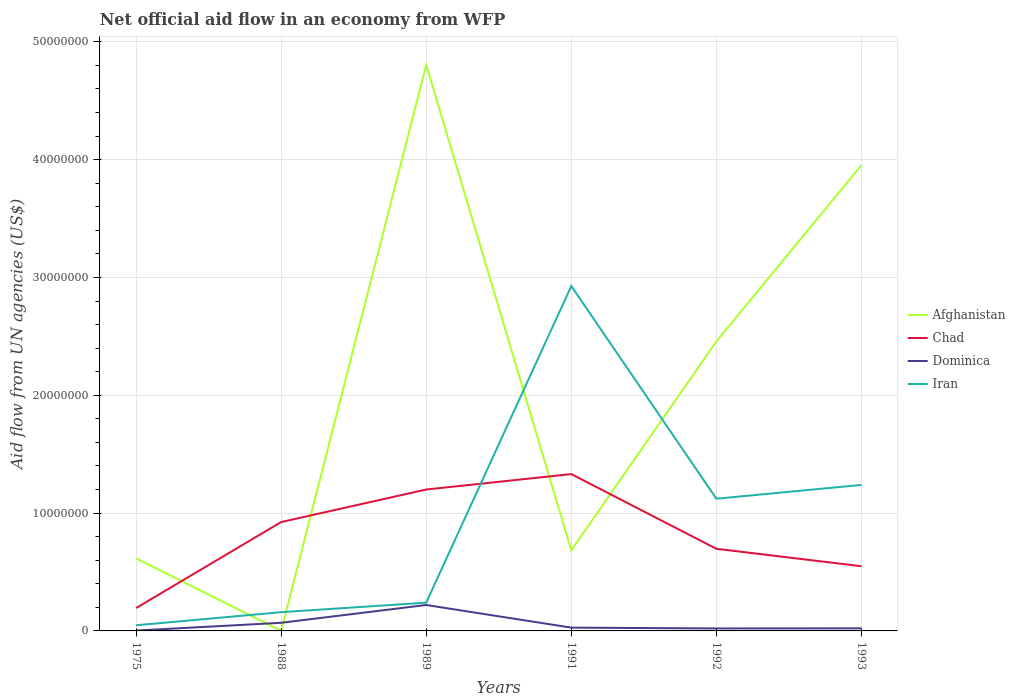Does the line corresponding to Afghanistan intersect with the line corresponding to Iran?
Give a very brief answer. Yes. Across all years, what is the maximum net official aid flow in Chad?
Provide a short and direct response. 1.94e+06. In which year was the net official aid flow in Afghanistan maximum?
Ensure brevity in your answer.  1988. What is the total net official aid flow in Chad in the graph?
Keep it short and to the point. 7.82e+06. What is the difference between the highest and the second highest net official aid flow in Chad?
Offer a very short reply. 1.14e+07. Is the net official aid flow in Dominica strictly greater than the net official aid flow in Chad over the years?
Make the answer very short. Yes. Does the graph contain grids?
Provide a succinct answer. Yes. What is the title of the graph?
Ensure brevity in your answer.  Net official aid flow in an economy from WFP. Does "Monaco" appear as one of the legend labels in the graph?
Your answer should be very brief. No. What is the label or title of the X-axis?
Your answer should be very brief. Years. What is the label or title of the Y-axis?
Keep it short and to the point. Aid flow from UN agencies (US$). What is the Aid flow from UN agencies (US$) in Afghanistan in 1975?
Your answer should be very brief. 6.16e+06. What is the Aid flow from UN agencies (US$) in Chad in 1975?
Keep it short and to the point. 1.94e+06. What is the Aid flow from UN agencies (US$) in Dominica in 1975?
Your answer should be very brief. 3.00e+04. What is the Aid flow from UN agencies (US$) in Iran in 1975?
Offer a terse response. 4.80e+05. What is the Aid flow from UN agencies (US$) in Afghanistan in 1988?
Provide a succinct answer. 10000. What is the Aid flow from UN agencies (US$) of Chad in 1988?
Offer a terse response. 9.24e+06. What is the Aid flow from UN agencies (US$) of Dominica in 1988?
Your answer should be compact. 6.90e+05. What is the Aid flow from UN agencies (US$) in Iran in 1988?
Your answer should be compact. 1.59e+06. What is the Aid flow from UN agencies (US$) in Afghanistan in 1989?
Your answer should be compact. 4.80e+07. What is the Aid flow from UN agencies (US$) of Chad in 1989?
Offer a very short reply. 1.20e+07. What is the Aid flow from UN agencies (US$) in Dominica in 1989?
Keep it short and to the point. 2.20e+06. What is the Aid flow from UN agencies (US$) of Iran in 1989?
Offer a terse response. 2.40e+06. What is the Aid flow from UN agencies (US$) in Afghanistan in 1991?
Ensure brevity in your answer.  6.84e+06. What is the Aid flow from UN agencies (US$) of Chad in 1991?
Provide a succinct answer. 1.33e+07. What is the Aid flow from UN agencies (US$) of Iran in 1991?
Provide a short and direct response. 2.93e+07. What is the Aid flow from UN agencies (US$) in Afghanistan in 1992?
Make the answer very short. 2.46e+07. What is the Aid flow from UN agencies (US$) in Chad in 1992?
Keep it short and to the point. 6.97e+06. What is the Aid flow from UN agencies (US$) in Iran in 1992?
Offer a terse response. 1.12e+07. What is the Aid flow from UN agencies (US$) of Afghanistan in 1993?
Make the answer very short. 3.95e+07. What is the Aid flow from UN agencies (US$) in Chad in 1993?
Ensure brevity in your answer.  5.49e+06. What is the Aid flow from UN agencies (US$) in Iran in 1993?
Offer a terse response. 1.24e+07. Across all years, what is the maximum Aid flow from UN agencies (US$) in Afghanistan?
Your answer should be very brief. 4.80e+07. Across all years, what is the maximum Aid flow from UN agencies (US$) of Chad?
Ensure brevity in your answer.  1.33e+07. Across all years, what is the maximum Aid flow from UN agencies (US$) in Dominica?
Your answer should be very brief. 2.20e+06. Across all years, what is the maximum Aid flow from UN agencies (US$) of Iran?
Ensure brevity in your answer.  2.93e+07. Across all years, what is the minimum Aid flow from UN agencies (US$) of Afghanistan?
Offer a very short reply. 10000. Across all years, what is the minimum Aid flow from UN agencies (US$) of Chad?
Your answer should be very brief. 1.94e+06. Across all years, what is the minimum Aid flow from UN agencies (US$) of Iran?
Make the answer very short. 4.80e+05. What is the total Aid flow from UN agencies (US$) of Afghanistan in the graph?
Offer a terse response. 1.25e+08. What is the total Aid flow from UN agencies (US$) in Chad in the graph?
Provide a short and direct response. 4.90e+07. What is the total Aid flow from UN agencies (US$) in Dominica in the graph?
Make the answer very short. 3.63e+06. What is the total Aid flow from UN agencies (US$) in Iran in the graph?
Provide a short and direct response. 5.74e+07. What is the difference between the Aid flow from UN agencies (US$) of Afghanistan in 1975 and that in 1988?
Provide a succinct answer. 6.15e+06. What is the difference between the Aid flow from UN agencies (US$) of Chad in 1975 and that in 1988?
Your response must be concise. -7.30e+06. What is the difference between the Aid flow from UN agencies (US$) of Dominica in 1975 and that in 1988?
Provide a short and direct response. -6.60e+05. What is the difference between the Aid flow from UN agencies (US$) of Iran in 1975 and that in 1988?
Offer a very short reply. -1.11e+06. What is the difference between the Aid flow from UN agencies (US$) of Afghanistan in 1975 and that in 1989?
Your response must be concise. -4.19e+07. What is the difference between the Aid flow from UN agencies (US$) of Chad in 1975 and that in 1989?
Your response must be concise. -1.01e+07. What is the difference between the Aid flow from UN agencies (US$) of Dominica in 1975 and that in 1989?
Your response must be concise. -2.17e+06. What is the difference between the Aid flow from UN agencies (US$) of Iran in 1975 and that in 1989?
Make the answer very short. -1.92e+06. What is the difference between the Aid flow from UN agencies (US$) of Afghanistan in 1975 and that in 1991?
Offer a terse response. -6.80e+05. What is the difference between the Aid flow from UN agencies (US$) in Chad in 1975 and that in 1991?
Provide a succinct answer. -1.14e+07. What is the difference between the Aid flow from UN agencies (US$) in Iran in 1975 and that in 1991?
Give a very brief answer. -2.88e+07. What is the difference between the Aid flow from UN agencies (US$) in Afghanistan in 1975 and that in 1992?
Make the answer very short. -1.84e+07. What is the difference between the Aid flow from UN agencies (US$) in Chad in 1975 and that in 1992?
Ensure brevity in your answer.  -5.03e+06. What is the difference between the Aid flow from UN agencies (US$) in Iran in 1975 and that in 1992?
Make the answer very short. -1.07e+07. What is the difference between the Aid flow from UN agencies (US$) of Afghanistan in 1975 and that in 1993?
Make the answer very short. -3.34e+07. What is the difference between the Aid flow from UN agencies (US$) of Chad in 1975 and that in 1993?
Offer a terse response. -3.55e+06. What is the difference between the Aid flow from UN agencies (US$) in Iran in 1975 and that in 1993?
Your response must be concise. -1.19e+07. What is the difference between the Aid flow from UN agencies (US$) of Afghanistan in 1988 and that in 1989?
Your response must be concise. -4.80e+07. What is the difference between the Aid flow from UN agencies (US$) of Chad in 1988 and that in 1989?
Make the answer very short. -2.76e+06. What is the difference between the Aid flow from UN agencies (US$) of Dominica in 1988 and that in 1989?
Provide a short and direct response. -1.51e+06. What is the difference between the Aid flow from UN agencies (US$) in Iran in 1988 and that in 1989?
Make the answer very short. -8.10e+05. What is the difference between the Aid flow from UN agencies (US$) of Afghanistan in 1988 and that in 1991?
Give a very brief answer. -6.83e+06. What is the difference between the Aid flow from UN agencies (US$) in Chad in 1988 and that in 1991?
Your response must be concise. -4.07e+06. What is the difference between the Aid flow from UN agencies (US$) in Iran in 1988 and that in 1991?
Offer a terse response. -2.77e+07. What is the difference between the Aid flow from UN agencies (US$) of Afghanistan in 1988 and that in 1992?
Your answer should be very brief. -2.46e+07. What is the difference between the Aid flow from UN agencies (US$) in Chad in 1988 and that in 1992?
Your answer should be very brief. 2.27e+06. What is the difference between the Aid flow from UN agencies (US$) in Dominica in 1988 and that in 1992?
Ensure brevity in your answer.  4.80e+05. What is the difference between the Aid flow from UN agencies (US$) of Iran in 1988 and that in 1992?
Your answer should be compact. -9.63e+06. What is the difference between the Aid flow from UN agencies (US$) in Afghanistan in 1988 and that in 1993?
Provide a succinct answer. -3.95e+07. What is the difference between the Aid flow from UN agencies (US$) of Chad in 1988 and that in 1993?
Make the answer very short. 3.75e+06. What is the difference between the Aid flow from UN agencies (US$) in Dominica in 1988 and that in 1993?
Offer a terse response. 4.70e+05. What is the difference between the Aid flow from UN agencies (US$) of Iran in 1988 and that in 1993?
Your response must be concise. -1.08e+07. What is the difference between the Aid flow from UN agencies (US$) of Afghanistan in 1989 and that in 1991?
Provide a succinct answer. 4.12e+07. What is the difference between the Aid flow from UN agencies (US$) in Chad in 1989 and that in 1991?
Provide a succinct answer. -1.31e+06. What is the difference between the Aid flow from UN agencies (US$) of Dominica in 1989 and that in 1991?
Your answer should be very brief. 1.92e+06. What is the difference between the Aid flow from UN agencies (US$) of Iran in 1989 and that in 1991?
Provide a short and direct response. -2.69e+07. What is the difference between the Aid flow from UN agencies (US$) in Afghanistan in 1989 and that in 1992?
Your answer should be compact. 2.35e+07. What is the difference between the Aid flow from UN agencies (US$) in Chad in 1989 and that in 1992?
Give a very brief answer. 5.03e+06. What is the difference between the Aid flow from UN agencies (US$) of Dominica in 1989 and that in 1992?
Offer a terse response. 1.99e+06. What is the difference between the Aid flow from UN agencies (US$) of Iran in 1989 and that in 1992?
Ensure brevity in your answer.  -8.82e+06. What is the difference between the Aid flow from UN agencies (US$) of Afghanistan in 1989 and that in 1993?
Your answer should be very brief. 8.51e+06. What is the difference between the Aid flow from UN agencies (US$) in Chad in 1989 and that in 1993?
Your answer should be very brief. 6.51e+06. What is the difference between the Aid flow from UN agencies (US$) in Dominica in 1989 and that in 1993?
Ensure brevity in your answer.  1.98e+06. What is the difference between the Aid flow from UN agencies (US$) of Iran in 1989 and that in 1993?
Keep it short and to the point. -9.99e+06. What is the difference between the Aid flow from UN agencies (US$) of Afghanistan in 1991 and that in 1992?
Give a very brief answer. -1.77e+07. What is the difference between the Aid flow from UN agencies (US$) of Chad in 1991 and that in 1992?
Ensure brevity in your answer.  6.34e+06. What is the difference between the Aid flow from UN agencies (US$) in Dominica in 1991 and that in 1992?
Offer a terse response. 7.00e+04. What is the difference between the Aid flow from UN agencies (US$) in Iran in 1991 and that in 1992?
Ensure brevity in your answer.  1.80e+07. What is the difference between the Aid flow from UN agencies (US$) of Afghanistan in 1991 and that in 1993?
Your answer should be very brief. -3.27e+07. What is the difference between the Aid flow from UN agencies (US$) of Chad in 1991 and that in 1993?
Your response must be concise. 7.82e+06. What is the difference between the Aid flow from UN agencies (US$) in Iran in 1991 and that in 1993?
Offer a very short reply. 1.69e+07. What is the difference between the Aid flow from UN agencies (US$) in Afghanistan in 1992 and that in 1993?
Ensure brevity in your answer.  -1.50e+07. What is the difference between the Aid flow from UN agencies (US$) of Chad in 1992 and that in 1993?
Give a very brief answer. 1.48e+06. What is the difference between the Aid flow from UN agencies (US$) of Dominica in 1992 and that in 1993?
Provide a short and direct response. -10000. What is the difference between the Aid flow from UN agencies (US$) in Iran in 1992 and that in 1993?
Offer a very short reply. -1.17e+06. What is the difference between the Aid flow from UN agencies (US$) of Afghanistan in 1975 and the Aid flow from UN agencies (US$) of Chad in 1988?
Your answer should be very brief. -3.08e+06. What is the difference between the Aid flow from UN agencies (US$) in Afghanistan in 1975 and the Aid flow from UN agencies (US$) in Dominica in 1988?
Offer a terse response. 5.47e+06. What is the difference between the Aid flow from UN agencies (US$) of Afghanistan in 1975 and the Aid flow from UN agencies (US$) of Iran in 1988?
Give a very brief answer. 4.57e+06. What is the difference between the Aid flow from UN agencies (US$) in Chad in 1975 and the Aid flow from UN agencies (US$) in Dominica in 1988?
Offer a very short reply. 1.25e+06. What is the difference between the Aid flow from UN agencies (US$) of Chad in 1975 and the Aid flow from UN agencies (US$) of Iran in 1988?
Your answer should be compact. 3.50e+05. What is the difference between the Aid flow from UN agencies (US$) of Dominica in 1975 and the Aid flow from UN agencies (US$) of Iran in 1988?
Offer a terse response. -1.56e+06. What is the difference between the Aid flow from UN agencies (US$) of Afghanistan in 1975 and the Aid flow from UN agencies (US$) of Chad in 1989?
Offer a terse response. -5.84e+06. What is the difference between the Aid flow from UN agencies (US$) in Afghanistan in 1975 and the Aid flow from UN agencies (US$) in Dominica in 1989?
Make the answer very short. 3.96e+06. What is the difference between the Aid flow from UN agencies (US$) of Afghanistan in 1975 and the Aid flow from UN agencies (US$) of Iran in 1989?
Your answer should be very brief. 3.76e+06. What is the difference between the Aid flow from UN agencies (US$) of Chad in 1975 and the Aid flow from UN agencies (US$) of Iran in 1989?
Your response must be concise. -4.60e+05. What is the difference between the Aid flow from UN agencies (US$) of Dominica in 1975 and the Aid flow from UN agencies (US$) of Iran in 1989?
Ensure brevity in your answer.  -2.37e+06. What is the difference between the Aid flow from UN agencies (US$) of Afghanistan in 1975 and the Aid flow from UN agencies (US$) of Chad in 1991?
Your response must be concise. -7.15e+06. What is the difference between the Aid flow from UN agencies (US$) of Afghanistan in 1975 and the Aid flow from UN agencies (US$) of Dominica in 1991?
Give a very brief answer. 5.88e+06. What is the difference between the Aid flow from UN agencies (US$) of Afghanistan in 1975 and the Aid flow from UN agencies (US$) of Iran in 1991?
Give a very brief answer. -2.31e+07. What is the difference between the Aid flow from UN agencies (US$) in Chad in 1975 and the Aid flow from UN agencies (US$) in Dominica in 1991?
Keep it short and to the point. 1.66e+06. What is the difference between the Aid flow from UN agencies (US$) in Chad in 1975 and the Aid flow from UN agencies (US$) in Iran in 1991?
Offer a very short reply. -2.73e+07. What is the difference between the Aid flow from UN agencies (US$) of Dominica in 1975 and the Aid flow from UN agencies (US$) of Iran in 1991?
Keep it short and to the point. -2.92e+07. What is the difference between the Aid flow from UN agencies (US$) of Afghanistan in 1975 and the Aid flow from UN agencies (US$) of Chad in 1992?
Your answer should be compact. -8.10e+05. What is the difference between the Aid flow from UN agencies (US$) of Afghanistan in 1975 and the Aid flow from UN agencies (US$) of Dominica in 1992?
Provide a short and direct response. 5.95e+06. What is the difference between the Aid flow from UN agencies (US$) in Afghanistan in 1975 and the Aid flow from UN agencies (US$) in Iran in 1992?
Keep it short and to the point. -5.06e+06. What is the difference between the Aid flow from UN agencies (US$) of Chad in 1975 and the Aid flow from UN agencies (US$) of Dominica in 1992?
Keep it short and to the point. 1.73e+06. What is the difference between the Aid flow from UN agencies (US$) in Chad in 1975 and the Aid flow from UN agencies (US$) in Iran in 1992?
Your answer should be compact. -9.28e+06. What is the difference between the Aid flow from UN agencies (US$) in Dominica in 1975 and the Aid flow from UN agencies (US$) in Iran in 1992?
Provide a short and direct response. -1.12e+07. What is the difference between the Aid flow from UN agencies (US$) in Afghanistan in 1975 and the Aid flow from UN agencies (US$) in Chad in 1993?
Offer a very short reply. 6.70e+05. What is the difference between the Aid flow from UN agencies (US$) of Afghanistan in 1975 and the Aid flow from UN agencies (US$) of Dominica in 1993?
Offer a very short reply. 5.94e+06. What is the difference between the Aid flow from UN agencies (US$) in Afghanistan in 1975 and the Aid flow from UN agencies (US$) in Iran in 1993?
Ensure brevity in your answer.  -6.23e+06. What is the difference between the Aid flow from UN agencies (US$) of Chad in 1975 and the Aid flow from UN agencies (US$) of Dominica in 1993?
Give a very brief answer. 1.72e+06. What is the difference between the Aid flow from UN agencies (US$) in Chad in 1975 and the Aid flow from UN agencies (US$) in Iran in 1993?
Keep it short and to the point. -1.04e+07. What is the difference between the Aid flow from UN agencies (US$) of Dominica in 1975 and the Aid flow from UN agencies (US$) of Iran in 1993?
Your answer should be compact. -1.24e+07. What is the difference between the Aid flow from UN agencies (US$) in Afghanistan in 1988 and the Aid flow from UN agencies (US$) in Chad in 1989?
Provide a short and direct response. -1.20e+07. What is the difference between the Aid flow from UN agencies (US$) in Afghanistan in 1988 and the Aid flow from UN agencies (US$) in Dominica in 1989?
Provide a succinct answer. -2.19e+06. What is the difference between the Aid flow from UN agencies (US$) of Afghanistan in 1988 and the Aid flow from UN agencies (US$) of Iran in 1989?
Keep it short and to the point. -2.39e+06. What is the difference between the Aid flow from UN agencies (US$) of Chad in 1988 and the Aid flow from UN agencies (US$) of Dominica in 1989?
Offer a very short reply. 7.04e+06. What is the difference between the Aid flow from UN agencies (US$) in Chad in 1988 and the Aid flow from UN agencies (US$) in Iran in 1989?
Your response must be concise. 6.84e+06. What is the difference between the Aid flow from UN agencies (US$) in Dominica in 1988 and the Aid flow from UN agencies (US$) in Iran in 1989?
Give a very brief answer. -1.71e+06. What is the difference between the Aid flow from UN agencies (US$) in Afghanistan in 1988 and the Aid flow from UN agencies (US$) in Chad in 1991?
Make the answer very short. -1.33e+07. What is the difference between the Aid flow from UN agencies (US$) of Afghanistan in 1988 and the Aid flow from UN agencies (US$) of Dominica in 1991?
Ensure brevity in your answer.  -2.70e+05. What is the difference between the Aid flow from UN agencies (US$) of Afghanistan in 1988 and the Aid flow from UN agencies (US$) of Iran in 1991?
Make the answer very short. -2.93e+07. What is the difference between the Aid flow from UN agencies (US$) of Chad in 1988 and the Aid flow from UN agencies (US$) of Dominica in 1991?
Your answer should be compact. 8.96e+06. What is the difference between the Aid flow from UN agencies (US$) of Chad in 1988 and the Aid flow from UN agencies (US$) of Iran in 1991?
Offer a terse response. -2.00e+07. What is the difference between the Aid flow from UN agencies (US$) in Dominica in 1988 and the Aid flow from UN agencies (US$) in Iran in 1991?
Ensure brevity in your answer.  -2.86e+07. What is the difference between the Aid flow from UN agencies (US$) in Afghanistan in 1988 and the Aid flow from UN agencies (US$) in Chad in 1992?
Ensure brevity in your answer.  -6.96e+06. What is the difference between the Aid flow from UN agencies (US$) of Afghanistan in 1988 and the Aid flow from UN agencies (US$) of Dominica in 1992?
Ensure brevity in your answer.  -2.00e+05. What is the difference between the Aid flow from UN agencies (US$) of Afghanistan in 1988 and the Aid flow from UN agencies (US$) of Iran in 1992?
Provide a succinct answer. -1.12e+07. What is the difference between the Aid flow from UN agencies (US$) in Chad in 1988 and the Aid flow from UN agencies (US$) in Dominica in 1992?
Offer a terse response. 9.03e+06. What is the difference between the Aid flow from UN agencies (US$) in Chad in 1988 and the Aid flow from UN agencies (US$) in Iran in 1992?
Offer a terse response. -1.98e+06. What is the difference between the Aid flow from UN agencies (US$) of Dominica in 1988 and the Aid flow from UN agencies (US$) of Iran in 1992?
Provide a succinct answer. -1.05e+07. What is the difference between the Aid flow from UN agencies (US$) in Afghanistan in 1988 and the Aid flow from UN agencies (US$) in Chad in 1993?
Ensure brevity in your answer.  -5.48e+06. What is the difference between the Aid flow from UN agencies (US$) in Afghanistan in 1988 and the Aid flow from UN agencies (US$) in Dominica in 1993?
Provide a short and direct response. -2.10e+05. What is the difference between the Aid flow from UN agencies (US$) of Afghanistan in 1988 and the Aid flow from UN agencies (US$) of Iran in 1993?
Your answer should be very brief. -1.24e+07. What is the difference between the Aid flow from UN agencies (US$) in Chad in 1988 and the Aid flow from UN agencies (US$) in Dominica in 1993?
Ensure brevity in your answer.  9.02e+06. What is the difference between the Aid flow from UN agencies (US$) of Chad in 1988 and the Aid flow from UN agencies (US$) of Iran in 1993?
Your response must be concise. -3.15e+06. What is the difference between the Aid flow from UN agencies (US$) in Dominica in 1988 and the Aid flow from UN agencies (US$) in Iran in 1993?
Offer a terse response. -1.17e+07. What is the difference between the Aid flow from UN agencies (US$) in Afghanistan in 1989 and the Aid flow from UN agencies (US$) in Chad in 1991?
Make the answer very short. 3.47e+07. What is the difference between the Aid flow from UN agencies (US$) of Afghanistan in 1989 and the Aid flow from UN agencies (US$) of Dominica in 1991?
Provide a succinct answer. 4.78e+07. What is the difference between the Aid flow from UN agencies (US$) of Afghanistan in 1989 and the Aid flow from UN agencies (US$) of Iran in 1991?
Give a very brief answer. 1.88e+07. What is the difference between the Aid flow from UN agencies (US$) of Chad in 1989 and the Aid flow from UN agencies (US$) of Dominica in 1991?
Offer a very short reply. 1.17e+07. What is the difference between the Aid flow from UN agencies (US$) of Chad in 1989 and the Aid flow from UN agencies (US$) of Iran in 1991?
Give a very brief answer. -1.73e+07. What is the difference between the Aid flow from UN agencies (US$) in Dominica in 1989 and the Aid flow from UN agencies (US$) in Iran in 1991?
Provide a succinct answer. -2.71e+07. What is the difference between the Aid flow from UN agencies (US$) of Afghanistan in 1989 and the Aid flow from UN agencies (US$) of Chad in 1992?
Offer a very short reply. 4.11e+07. What is the difference between the Aid flow from UN agencies (US$) of Afghanistan in 1989 and the Aid flow from UN agencies (US$) of Dominica in 1992?
Your answer should be very brief. 4.78e+07. What is the difference between the Aid flow from UN agencies (US$) of Afghanistan in 1989 and the Aid flow from UN agencies (US$) of Iran in 1992?
Offer a terse response. 3.68e+07. What is the difference between the Aid flow from UN agencies (US$) in Chad in 1989 and the Aid flow from UN agencies (US$) in Dominica in 1992?
Provide a succinct answer. 1.18e+07. What is the difference between the Aid flow from UN agencies (US$) of Chad in 1989 and the Aid flow from UN agencies (US$) of Iran in 1992?
Ensure brevity in your answer.  7.80e+05. What is the difference between the Aid flow from UN agencies (US$) in Dominica in 1989 and the Aid flow from UN agencies (US$) in Iran in 1992?
Your answer should be compact. -9.02e+06. What is the difference between the Aid flow from UN agencies (US$) of Afghanistan in 1989 and the Aid flow from UN agencies (US$) of Chad in 1993?
Your response must be concise. 4.26e+07. What is the difference between the Aid flow from UN agencies (US$) of Afghanistan in 1989 and the Aid flow from UN agencies (US$) of Dominica in 1993?
Your answer should be very brief. 4.78e+07. What is the difference between the Aid flow from UN agencies (US$) of Afghanistan in 1989 and the Aid flow from UN agencies (US$) of Iran in 1993?
Offer a very short reply. 3.56e+07. What is the difference between the Aid flow from UN agencies (US$) of Chad in 1989 and the Aid flow from UN agencies (US$) of Dominica in 1993?
Give a very brief answer. 1.18e+07. What is the difference between the Aid flow from UN agencies (US$) in Chad in 1989 and the Aid flow from UN agencies (US$) in Iran in 1993?
Your answer should be very brief. -3.90e+05. What is the difference between the Aid flow from UN agencies (US$) in Dominica in 1989 and the Aid flow from UN agencies (US$) in Iran in 1993?
Ensure brevity in your answer.  -1.02e+07. What is the difference between the Aid flow from UN agencies (US$) in Afghanistan in 1991 and the Aid flow from UN agencies (US$) in Chad in 1992?
Offer a terse response. -1.30e+05. What is the difference between the Aid flow from UN agencies (US$) in Afghanistan in 1991 and the Aid flow from UN agencies (US$) in Dominica in 1992?
Provide a succinct answer. 6.63e+06. What is the difference between the Aid flow from UN agencies (US$) of Afghanistan in 1991 and the Aid flow from UN agencies (US$) of Iran in 1992?
Give a very brief answer. -4.38e+06. What is the difference between the Aid flow from UN agencies (US$) in Chad in 1991 and the Aid flow from UN agencies (US$) in Dominica in 1992?
Your answer should be very brief. 1.31e+07. What is the difference between the Aid flow from UN agencies (US$) in Chad in 1991 and the Aid flow from UN agencies (US$) in Iran in 1992?
Provide a succinct answer. 2.09e+06. What is the difference between the Aid flow from UN agencies (US$) of Dominica in 1991 and the Aid flow from UN agencies (US$) of Iran in 1992?
Make the answer very short. -1.09e+07. What is the difference between the Aid flow from UN agencies (US$) of Afghanistan in 1991 and the Aid flow from UN agencies (US$) of Chad in 1993?
Your response must be concise. 1.35e+06. What is the difference between the Aid flow from UN agencies (US$) in Afghanistan in 1991 and the Aid flow from UN agencies (US$) in Dominica in 1993?
Offer a very short reply. 6.62e+06. What is the difference between the Aid flow from UN agencies (US$) of Afghanistan in 1991 and the Aid flow from UN agencies (US$) of Iran in 1993?
Make the answer very short. -5.55e+06. What is the difference between the Aid flow from UN agencies (US$) in Chad in 1991 and the Aid flow from UN agencies (US$) in Dominica in 1993?
Provide a short and direct response. 1.31e+07. What is the difference between the Aid flow from UN agencies (US$) of Chad in 1991 and the Aid flow from UN agencies (US$) of Iran in 1993?
Ensure brevity in your answer.  9.20e+05. What is the difference between the Aid flow from UN agencies (US$) in Dominica in 1991 and the Aid flow from UN agencies (US$) in Iran in 1993?
Your response must be concise. -1.21e+07. What is the difference between the Aid flow from UN agencies (US$) in Afghanistan in 1992 and the Aid flow from UN agencies (US$) in Chad in 1993?
Provide a short and direct response. 1.91e+07. What is the difference between the Aid flow from UN agencies (US$) of Afghanistan in 1992 and the Aid flow from UN agencies (US$) of Dominica in 1993?
Make the answer very short. 2.44e+07. What is the difference between the Aid flow from UN agencies (US$) of Afghanistan in 1992 and the Aid flow from UN agencies (US$) of Iran in 1993?
Your response must be concise. 1.22e+07. What is the difference between the Aid flow from UN agencies (US$) of Chad in 1992 and the Aid flow from UN agencies (US$) of Dominica in 1993?
Offer a terse response. 6.75e+06. What is the difference between the Aid flow from UN agencies (US$) in Chad in 1992 and the Aid flow from UN agencies (US$) in Iran in 1993?
Your answer should be very brief. -5.42e+06. What is the difference between the Aid flow from UN agencies (US$) in Dominica in 1992 and the Aid flow from UN agencies (US$) in Iran in 1993?
Your answer should be compact. -1.22e+07. What is the average Aid flow from UN agencies (US$) in Afghanistan per year?
Give a very brief answer. 2.09e+07. What is the average Aid flow from UN agencies (US$) in Chad per year?
Keep it short and to the point. 8.16e+06. What is the average Aid flow from UN agencies (US$) in Dominica per year?
Ensure brevity in your answer.  6.05e+05. What is the average Aid flow from UN agencies (US$) of Iran per year?
Your answer should be compact. 9.56e+06. In the year 1975, what is the difference between the Aid flow from UN agencies (US$) of Afghanistan and Aid flow from UN agencies (US$) of Chad?
Provide a succinct answer. 4.22e+06. In the year 1975, what is the difference between the Aid flow from UN agencies (US$) in Afghanistan and Aid flow from UN agencies (US$) in Dominica?
Give a very brief answer. 6.13e+06. In the year 1975, what is the difference between the Aid flow from UN agencies (US$) of Afghanistan and Aid flow from UN agencies (US$) of Iran?
Your answer should be compact. 5.68e+06. In the year 1975, what is the difference between the Aid flow from UN agencies (US$) in Chad and Aid flow from UN agencies (US$) in Dominica?
Provide a short and direct response. 1.91e+06. In the year 1975, what is the difference between the Aid flow from UN agencies (US$) in Chad and Aid flow from UN agencies (US$) in Iran?
Provide a short and direct response. 1.46e+06. In the year 1975, what is the difference between the Aid flow from UN agencies (US$) in Dominica and Aid flow from UN agencies (US$) in Iran?
Offer a very short reply. -4.50e+05. In the year 1988, what is the difference between the Aid flow from UN agencies (US$) in Afghanistan and Aid flow from UN agencies (US$) in Chad?
Your answer should be very brief. -9.23e+06. In the year 1988, what is the difference between the Aid flow from UN agencies (US$) of Afghanistan and Aid flow from UN agencies (US$) of Dominica?
Give a very brief answer. -6.80e+05. In the year 1988, what is the difference between the Aid flow from UN agencies (US$) in Afghanistan and Aid flow from UN agencies (US$) in Iran?
Provide a short and direct response. -1.58e+06. In the year 1988, what is the difference between the Aid flow from UN agencies (US$) of Chad and Aid flow from UN agencies (US$) of Dominica?
Offer a terse response. 8.55e+06. In the year 1988, what is the difference between the Aid flow from UN agencies (US$) in Chad and Aid flow from UN agencies (US$) in Iran?
Provide a short and direct response. 7.65e+06. In the year 1988, what is the difference between the Aid flow from UN agencies (US$) in Dominica and Aid flow from UN agencies (US$) in Iran?
Ensure brevity in your answer.  -9.00e+05. In the year 1989, what is the difference between the Aid flow from UN agencies (US$) of Afghanistan and Aid flow from UN agencies (US$) of Chad?
Ensure brevity in your answer.  3.60e+07. In the year 1989, what is the difference between the Aid flow from UN agencies (US$) of Afghanistan and Aid flow from UN agencies (US$) of Dominica?
Provide a short and direct response. 4.58e+07. In the year 1989, what is the difference between the Aid flow from UN agencies (US$) in Afghanistan and Aid flow from UN agencies (US$) in Iran?
Your answer should be very brief. 4.56e+07. In the year 1989, what is the difference between the Aid flow from UN agencies (US$) of Chad and Aid flow from UN agencies (US$) of Dominica?
Your response must be concise. 9.80e+06. In the year 1989, what is the difference between the Aid flow from UN agencies (US$) of Chad and Aid flow from UN agencies (US$) of Iran?
Your answer should be very brief. 9.60e+06. In the year 1989, what is the difference between the Aid flow from UN agencies (US$) of Dominica and Aid flow from UN agencies (US$) of Iran?
Your answer should be very brief. -2.00e+05. In the year 1991, what is the difference between the Aid flow from UN agencies (US$) of Afghanistan and Aid flow from UN agencies (US$) of Chad?
Your answer should be very brief. -6.47e+06. In the year 1991, what is the difference between the Aid flow from UN agencies (US$) in Afghanistan and Aid flow from UN agencies (US$) in Dominica?
Ensure brevity in your answer.  6.56e+06. In the year 1991, what is the difference between the Aid flow from UN agencies (US$) in Afghanistan and Aid flow from UN agencies (US$) in Iran?
Provide a short and direct response. -2.24e+07. In the year 1991, what is the difference between the Aid flow from UN agencies (US$) of Chad and Aid flow from UN agencies (US$) of Dominica?
Provide a short and direct response. 1.30e+07. In the year 1991, what is the difference between the Aid flow from UN agencies (US$) of Chad and Aid flow from UN agencies (US$) of Iran?
Provide a short and direct response. -1.60e+07. In the year 1991, what is the difference between the Aid flow from UN agencies (US$) in Dominica and Aid flow from UN agencies (US$) in Iran?
Provide a succinct answer. -2.90e+07. In the year 1992, what is the difference between the Aid flow from UN agencies (US$) of Afghanistan and Aid flow from UN agencies (US$) of Chad?
Keep it short and to the point. 1.76e+07. In the year 1992, what is the difference between the Aid flow from UN agencies (US$) in Afghanistan and Aid flow from UN agencies (US$) in Dominica?
Your answer should be compact. 2.44e+07. In the year 1992, what is the difference between the Aid flow from UN agencies (US$) in Afghanistan and Aid flow from UN agencies (US$) in Iran?
Provide a succinct answer. 1.34e+07. In the year 1992, what is the difference between the Aid flow from UN agencies (US$) in Chad and Aid flow from UN agencies (US$) in Dominica?
Offer a terse response. 6.76e+06. In the year 1992, what is the difference between the Aid flow from UN agencies (US$) in Chad and Aid flow from UN agencies (US$) in Iran?
Provide a short and direct response. -4.25e+06. In the year 1992, what is the difference between the Aid flow from UN agencies (US$) in Dominica and Aid flow from UN agencies (US$) in Iran?
Provide a short and direct response. -1.10e+07. In the year 1993, what is the difference between the Aid flow from UN agencies (US$) in Afghanistan and Aid flow from UN agencies (US$) in Chad?
Provide a short and direct response. 3.40e+07. In the year 1993, what is the difference between the Aid flow from UN agencies (US$) of Afghanistan and Aid flow from UN agencies (US$) of Dominica?
Give a very brief answer. 3.93e+07. In the year 1993, what is the difference between the Aid flow from UN agencies (US$) in Afghanistan and Aid flow from UN agencies (US$) in Iran?
Your answer should be very brief. 2.71e+07. In the year 1993, what is the difference between the Aid flow from UN agencies (US$) of Chad and Aid flow from UN agencies (US$) of Dominica?
Keep it short and to the point. 5.27e+06. In the year 1993, what is the difference between the Aid flow from UN agencies (US$) of Chad and Aid flow from UN agencies (US$) of Iran?
Your response must be concise. -6.90e+06. In the year 1993, what is the difference between the Aid flow from UN agencies (US$) in Dominica and Aid flow from UN agencies (US$) in Iran?
Provide a short and direct response. -1.22e+07. What is the ratio of the Aid flow from UN agencies (US$) in Afghanistan in 1975 to that in 1988?
Keep it short and to the point. 616. What is the ratio of the Aid flow from UN agencies (US$) of Chad in 1975 to that in 1988?
Keep it short and to the point. 0.21. What is the ratio of the Aid flow from UN agencies (US$) of Dominica in 1975 to that in 1988?
Ensure brevity in your answer.  0.04. What is the ratio of the Aid flow from UN agencies (US$) in Iran in 1975 to that in 1988?
Offer a very short reply. 0.3. What is the ratio of the Aid flow from UN agencies (US$) in Afghanistan in 1975 to that in 1989?
Offer a very short reply. 0.13. What is the ratio of the Aid flow from UN agencies (US$) of Chad in 1975 to that in 1989?
Keep it short and to the point. 0.16. What is the ratio of the Aid flow from UN agencies (US$) in Dominica in 1975 to that in 1989?
Your answer should be very brief. 0.01. What is the ratio of the Aid flow from UN agencies (US$) in Iran in 1975 to that in 1989?
Give a very brief answer. 0.2. What is the ratio of the Aid flow from UN agencies (US$) of Afghanistan in 1975 to that in 1991?
Keep it short and to the point. 0.9. What is the ratio of the Aid flow from UN agencies (US$) of Chad in 1975 to that in 1991?
Make the answer very short. 0.15. What is the ratio of the Aid flow from UN agencies (US$) in Dominica in 1975 to that in 1991?
Give a very brief answer. 0.11. What is the ratio of the Aid flow from UN agencies (US$) in Iran in 1975 to that in 1991?
Keep it short and to the point. 0.02. What is the ratio of the Aid flow from UN agencies (US$) of Afghanistan in 1975 to that in 1992?
Offer a terse response. 0.25. What is the ratio of the Aid flow from UN agencies (US$) of Chad in 1975 to that in 1992?
Offer a terse response. 0.28. What is the ratio of the Aid flow from UN agencies (US$) of Dominica in 1975 to that in 1992?
Your answer should be compact. 0.14. What is the ratio of the Aid flow from UN agencies (US$) of Iran in 1975 to that in 1992?
Offer a very short reply. 0.04. What is the ratio of the Aid flow from UN agencies (US$) in Afghanistan in 1975 to that in 1993?
Your answer should be very brief. 0.16. What is the ratio of the Aid flow from UN agencies (US$) in Chad in 1975 to that in 1993?
Ensure brevity in your answer.  0.35. What is the ratio of the Aid flow from UN agencies (US$) of Dominica in 1975 to that in 1993?
Make the answer very short. 0.14. What is the ratio of the Aid flow from UN agencies (US$) of Iran in 1975 to that in 1993?
Offer a very short reply. 0.04. What is the ratio of the Aid flow from UN agencies (US$) of Afghanistan in 1988 to that in 1989?
Ensure brevity in your answer.  0. What is the ratio of the Aid flow from UN agencies (US$) of Chad in 1988 to that in 1989?
Provide a short and direct response. 0.77. What is the ratio of the Aid flow from UN agencies (US$) of Dominica in 1988 to that in 1989?
Your answer should be very brief. 0.31. What is the ratio of the Aid flow from UN agencies (US$) in Iran in 1988 to that in 1989?
Offer a terse response. 0.66. What is the ratio of the Aid flow from UN agencies (US$) in Afghanistan in 1988 to that in 1991?
Provide a succinct answer. 0. What is the ratio of the Aid flow from UN agencies (US$) of Chad in 1988 to that in 1991?
Your answer should be very brief. 0.69. What is the ratio of the Aid flow from UN agencies (US$) in Dominica in 1988 to that in 1991?
Your response must be concise. 2.46. What is the ratio of the Aid flow from UN agencies (US$) in Iran in 1988 to that in 1991?
Your answer should be compact. 0.05. What is the ratio of the Aid flow from UN agencies (US$) of Chad in 1988 to that in 1992?
Make the answer very short. 1.33. What is the ratio of the Aid flow from UN agencies (US$) of Dominica in 1988 to that in 1992?
Make the answer very short. 3.29. What is the ratio of the Aid flow from UN agencies (US$) of Iran in 1988 to that in 1992?
Keep it short and to the point. 0.14. What is the ratio of the Aid flow from UN agencies (US$) in Chad in 1988 to that in 1993?
Your answer should be compact. 1.68. What is the ratio of the Aid flow from UN agencies (US$) of Dominica in 1988 to that in 1993?
Give a very brief answer. 3.14. What is the ratio of the Aid flow from UN agencies (US$) of Iran in 1988 to that in 1993?
Provide a short and direct response. 0.13. What is the ratio of the Aid flow from UN agencies (US$) of Afghanistan in 1989 to that in 1991?
Provide a short and direct response. 7.02. What is the ratio of the Aid flow from UN agencies (US$) of Chad in 1989 to that in 1991?
Offer a terse response. 0.9. What is the ratio of the Aid flow from UN agencies (US$) in Dominica in 1989 to that in 1991?
Provide a succinct answer. 7.86. What is the ratio of the Aid flow from UN agencies (US$) of Iran in 1989 to that in 1991?
Give a very brief answer. 0.08. What is the ratio of the Aid flow from UN agencies (US$) of Afghanistan in 1989 to that in 1992?
Ensure brevity in your answer.  1.96. What is the ratio of the Aid flow from UN agencies (US$) of Chad in 1989 to that in 1992?
Offer a terse response. 1.72. What is the ratio of the Aid flow from UN agencies (US$) of Dominica in 1989 to that in 1992?
Your answer should be compact. 10.48. What is the ratio of the Aid flow from UN agencies (US$) of Iran in 1989 to that in 1992?
Provide a succinct answer. 0.21. What is the ratio of the Aid flow from UN agencies (US$) in Afghanistan in 1989 to that in 1993?
Provide a succinct answer. 1.22. What is the ratio of the Aid flow from UN agencies (US$) in Chad in 1989 to that in 1993?
Provide a short and direct response. 2.19. What is the ratio of the Aid flow from UN agencies (US$) of Dominica in 1989 to that in 1993?
Your response must be concise. 10. What is the ratio of the Aid flow from UN agencies (US$) in Iran in 1989 to that in 1993?
Your answer should be compact. 0.19. What is the ratio of the Aid flow from UN agencies (US$) in Afghanistan in 1991 to that in 1992?
Keep it short and to the point. 0.28. What is the ratio of the Aid flow from UN agencies (US$) in Chad in 1991 to that in 1992?
Ensure brevity in your answer.  1.91. What is the ratio of the Aid flow from UN agencies (US$) in Dominica in 1991 to that in 1992?
Provide a short and direct response. 1.33. What is the ratio of the Aid flow from UN agencies (US$) in Iran in 1991 to that in 1992?
Keep it short and to the point. 2.61. What is the ratio of the Aid flow from UN agencies (US$) in Afghanistan in 1991 to that in 1993?
Offer a terse response. 0.17. What is the ratio of the Aid flow from UN agencies (US$) in Chad in 1991 to that in 1993?
Provide a succinct answer. 2.42. What is the ratio of the Aid flow from UN agencies (US$) in Dominica in 1991 to that in 1993?
Make the answer very short. 1.27. What is the ratio of the Aid flow from UN agencies (US$) in Iran in 1991 to that in 1993?
Ensure brevity in your answer.  2.36. What is the ratio of the Aid flow from UN agencies (US$) in Afghanistan in 1992 to that in 1993?
Your answer should be compact. 0.62. What is the ratio of the Aid flow from UN agencies (US$) of Chad in 1992 to that in 1993?
Your answer should be very brief. 1.27. What is the ratio of the Aid flow from UN agencies (US$) in Dominica in 1992 to that in 1993?
Your answer should be compact. 0.95. What is the ratio of the Aid flow from UN agencies (US$) of Iran in 1992 to that in 1993?
Ensure brevity in your answer.  0.91. What is the difference between the highest and the second highest Aid flow from UN agencies (US$) in Afghanistan?
Offer a very short reply. 8.51e+06. What is the difference between the highest and the second highest Aid flow from UN agencies (US$) of Chad?
Ensure brevity in your answer.  1.31e+06. What is the difference between the highest and the second highest Aid flow from UN agencies (US$) in Dominica?
Your answer should be very brief. 1.51e+06. What is the difference between the highest and the second highest Aid flow from UN agencies (US$) of Iran?
Your answer should be very brief. 1.69e+07. What is the difference between the highest and the lowest Aid flow from UN agencies (US$) of Afghanistan?
Provide a short and direct response. 4.80e+07. What is the difference between the highest and the lowest Aid flow from UN agencies (US$) of Chad?
Provide a succinct answer. 1.14e+07. What is the difference between the highest and the lowest Aid flow from UN agencies (US$) in Dominica?
Offer a terse response. 2.17e+06. What is the difference between the highest and the lowest Aid flow from UN agencies (US$) of Iran?
Give a very brief answer. 2.88e+07. 